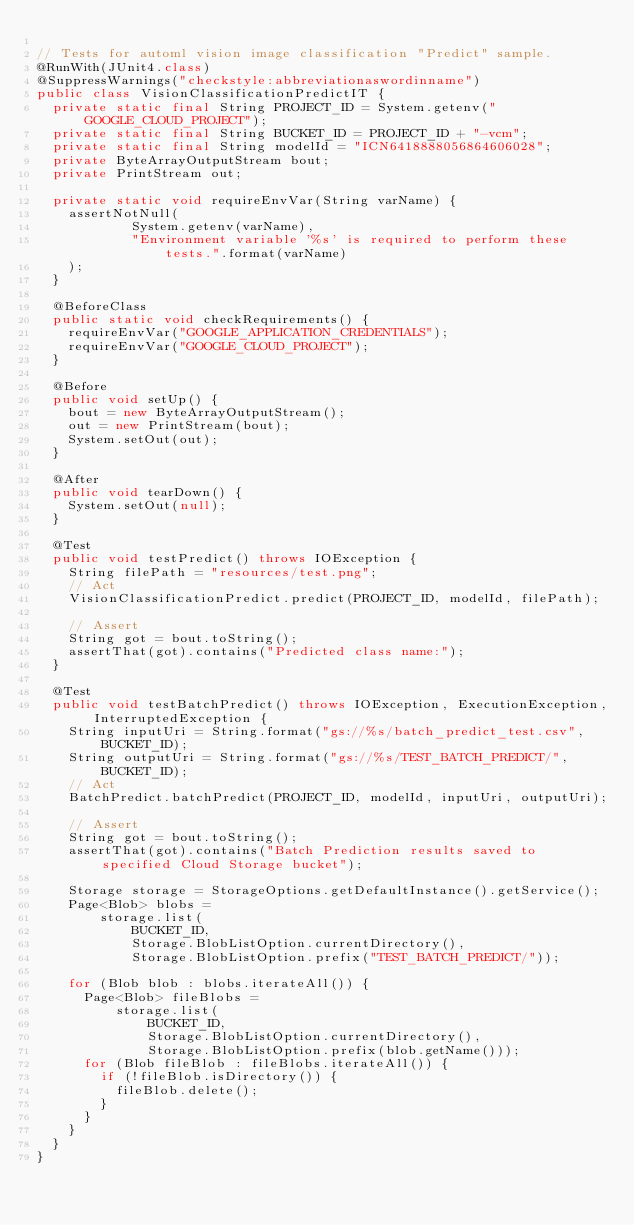Convert code to text. <code><loc_0><loc_0><loc_500><loc_500><_Java_>
// Tests for automl vision image classification "Predict" sample.
@RunWith(JUnit4.class)
@SuppressWarnings("checkstyle:abbreviationaswordinname")
public class VisionClassificationPredictIT {
  private static final String PROJECT_ID = System.getenv("GOOGLE_CLOUD_PROJECT");
  private static final String BUCKET_ID = PROJECT_ID + "-vcm";
  private static final String modelId = "ICN6418888056864606028";
  private ByteArrayOutputStream bout;
  private PrintStream out;

  private static void requireEnvVar(String varName) {
    assertNotNull(
            System.getenv(varName),
            "Environment variable '%s' is required to perform these tests.".format(varName)
    );
  }

  @BeforeClass
  public static void checkRequirements() {
    requireEnvVar("GOOGLE_APPLICATION_CREDENTIALS");
    requireEnvVar("GOOGLE_CLOUD_PROJECT");
  }

  @Before
  public void setUp() {
    bout = new ByteArrayOutputStream();
    out = new PrintStream(bout);
    System.setOut(out);
  }

  @After
  public void tearDown() {
    System.setOut(null);
  }

  @Test
  public void testPredict() throws IOException {
    String filePath = "resources/test.png";
    // Act
    VisionClassificationPredict.predict(PROJECT_ID, modelId, filePath);

    // Assert
    String got = bout.toString();
    assertThat(got).contains("Predicted class name:");
  }

  @Test
  public void testBatchPredict() throws IOException, ExecutionException, InterruptedException {
    String inputUri = String.format("gs://%s/batch_predict_test.csv", BUCKET_ID);
    String outputUri = String.format("gs://%s/TEST_BATCH_PREDICT/", BUCKET_ID);
    // Act
    BatchPredict.batchPredict(PROJECT_ID, modelId, inputUri, outputUri);

    // Assert
    String got = bout.toString();
    assertThat(got).contains("Batch Prediction results saved to specified Cloud Storage bucket");

    Storage storage = StorageOptions.getDefaultInstance().getService();
    Page<Blob> blobs =
        storage.list(
            BUCKET_ID,
            Storage.BlobListOption.currentDirectory(),
            Storage.BlobListOption.prefix("TEST_BATCH_PREDICT/"));

    for (Blob blob : blobs.iterateAll()) {
      Page<Blob> fileBlobs =
          storage.list(
              BUCKET_ID,
              Storage.BlobListOption.currentDirectory(),
              Storage.BlobListOption.prefix(blob.getName()));
      for (Blob fileBlob : fileBlobs.iterateAll()) {
        if (!fileBlob.isDirectory()) {
          fileBlob.delete();
        }
      }
    }
  }
}
</code> 